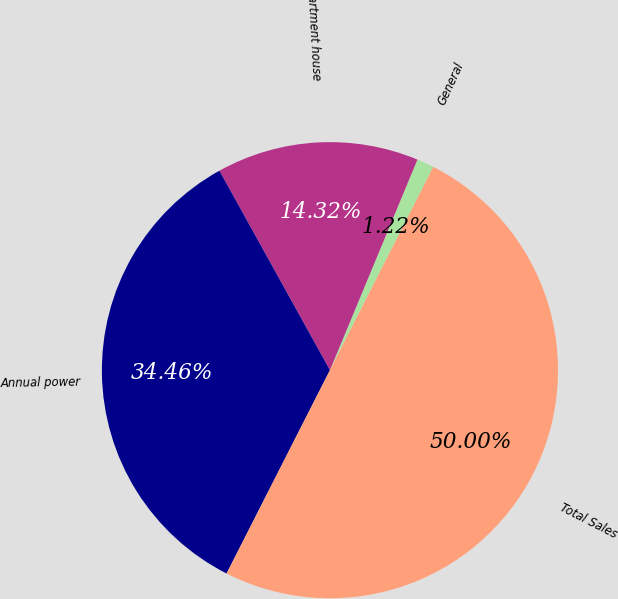Convert chart. <chart><loc_0><loc_0><loc_500><loc_500><pie_chart><fcel>General<fcel>Apartment house<fcel>Annual power<fcel>Total Sales<nl><fcel>1.22%<fcel>14.32%<fcel>34.46%<fcel>50.0%<nl></chart> 